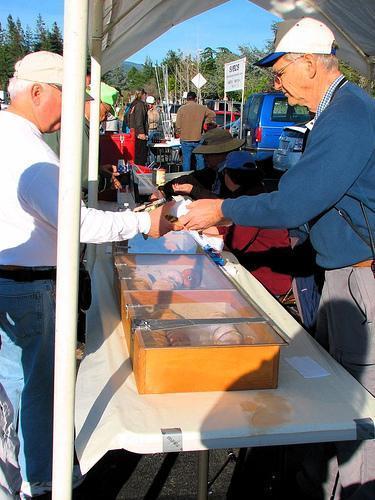How many cars are in the photo?
Give a very brief answer. 1. How many people are there?
Give a very brief answer. 4. How many of the train cars are yellow and red?
Give a very brief answer. 0. 